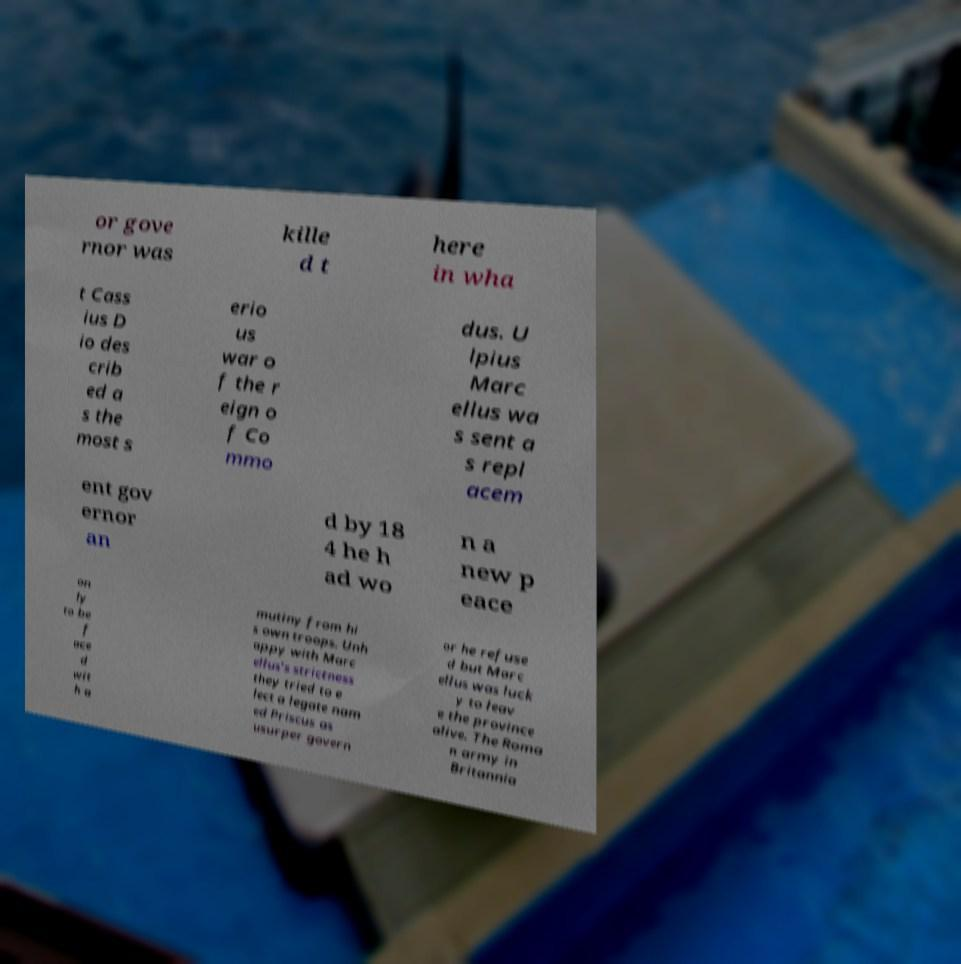Please read and relay the text visible in this image. What does it say? or gove rnor was kille d t here in wha t Cass ius D io des crib ed a s the most s erio us war o f the r eign o f Co mmo dus. U lpius Marc ellus wa s sent a s repl acem ent gov ernor an d by 18 4 he h ad wo n a new p eace on ly to be f ace d wit h a mutiny from hi s own troops. Unh appy with Marc ellus's strictness they tried to e lect a legate nam ed Priscus as usurper govern or he refuse d but Marc ellus was luck y to leav e the province alive. The Roma n army in Britannia 